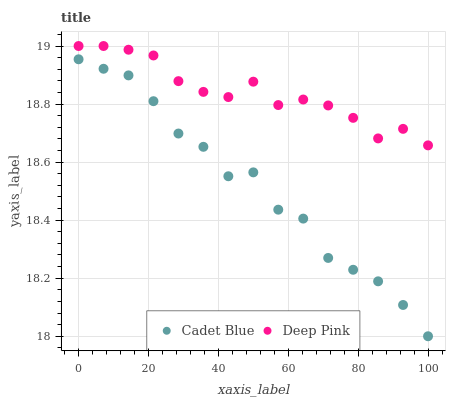Does Cadet Blue have the minimum area under the curve?
Answer yes or no. Yes. Does Deep Pink have the maximum area under the curve?
Answer yes or no. Yes. Does Deep Pink have the minimum area under the curve?
Answer yes or no. No. Is Deep Pink the smoothest?
Answer yes or no. Yes. Is Cadet Blue the roughest?
Answer yes or no. Yes. Is Deep Pink the roughest?
Answer yes or no. No. Does Cadet Blue have the lowest value?
Answer yes or no. Yes. Does Deep Pink have the lowest value?
Answer yes or no. No. Does Deep Pink have the highest value?
Answer yes or no. Yes. Is Cadet Blue less than Deep Pink?
Answer yes or no. Yes. Is Deep Pink greater than Cadet Blue?
Answer yes or no. Yes. Does Cadet Blue intersect Deep Pink?
Answer yes or no. No. 